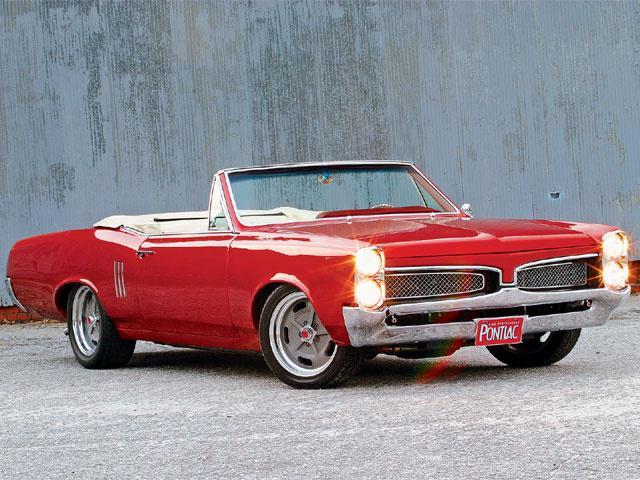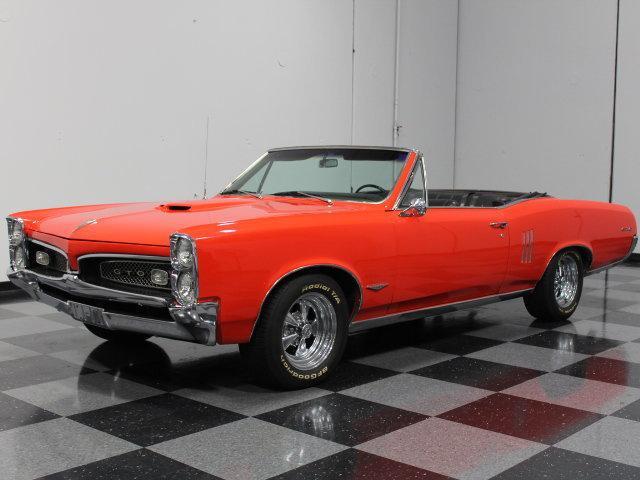The first image is the image on the left, the second image is the image on the right. Evaluate the accuracy of this statement regarding the images: "At least one vehicle is not red or pink.". Is it true? Answer yes or no. No. 